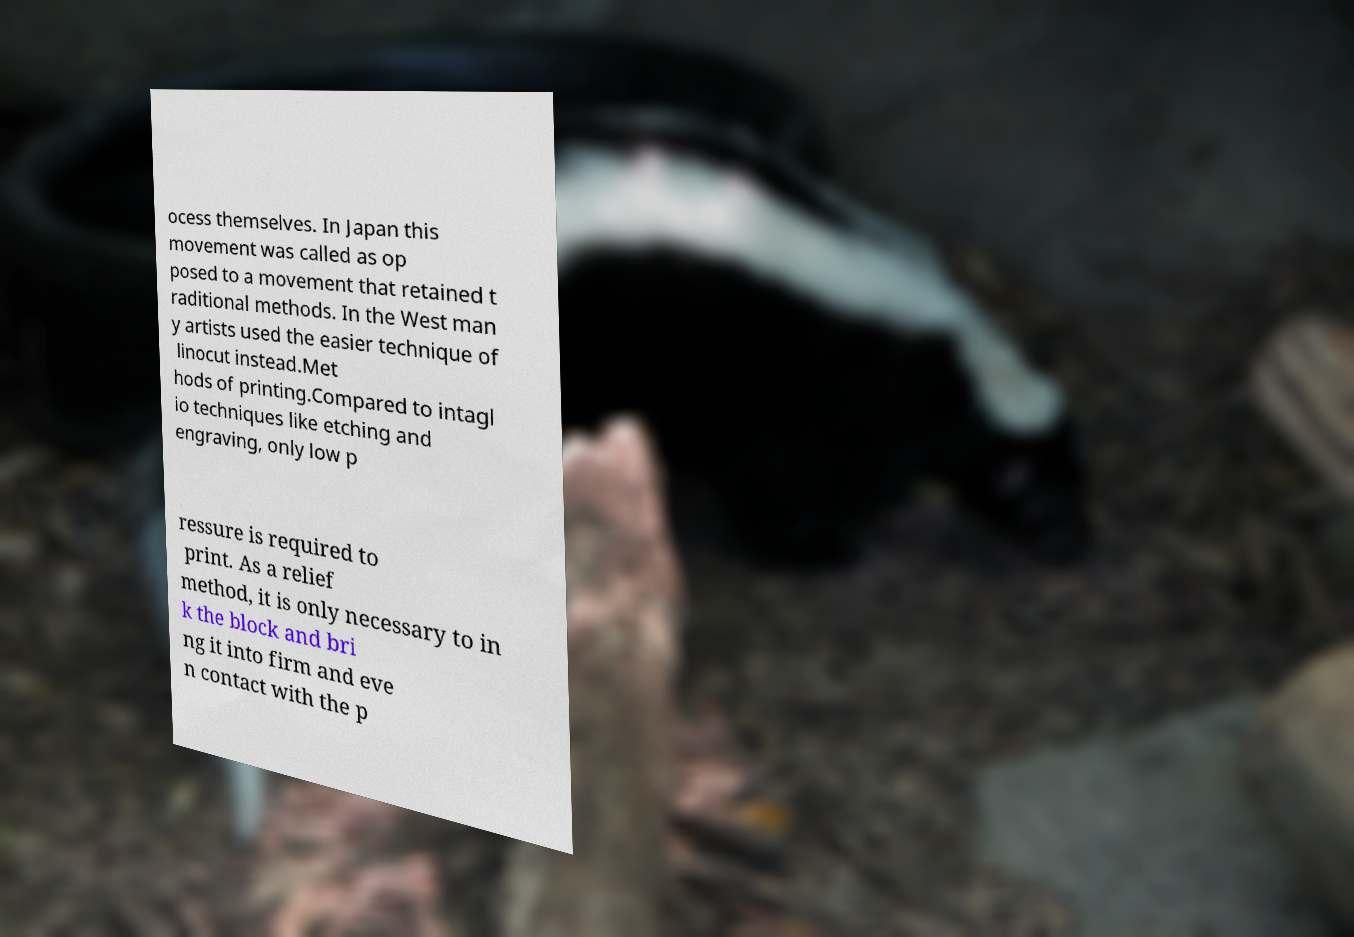For documentation purposes, I need the text within this image transcribed. Could you provide that? ocess themselves. In Japan this movement was called as op posed to a movement that retained t raditional methods. In the West man y artists used the easier technique of linocut instead.Met hods of printing.Compared to intagl io techniques like etching and engraving, only low p ressure is required to print. As a relief method, it is only necessary to in k the block and bri ng it into firm and eve n contact with the p 